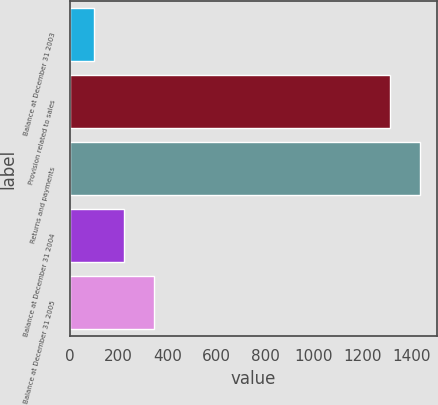<chart> <loc_0><loc_0><loc_500><loc_500><bar_chart><fcel>Balance at December 31 2003<fcel>Provision related to sales<fcel>Returns and payments<fcel>Balance at December 31 2004<fcel>Balance at December 31 2005<nl><fcel>101<fcel>1314<fcel>1435.3<fcel>222.3<fcel>343.6<nl></chart> 